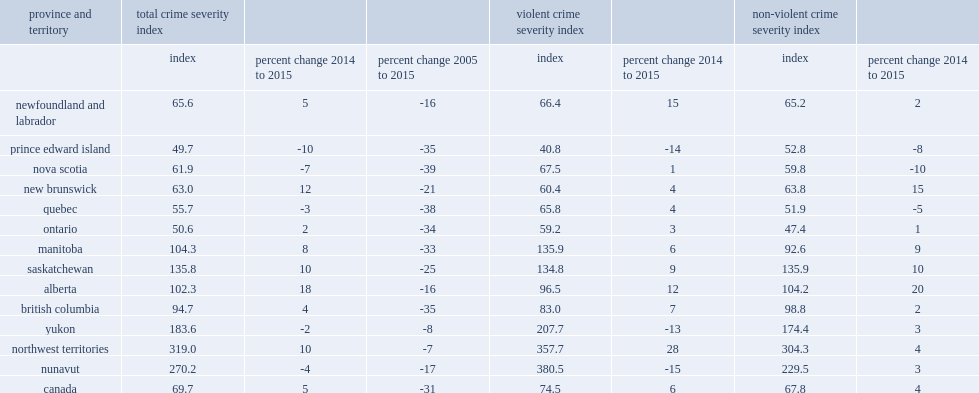About half of the increase in the national csi in 2015 can be explained by a large increase in police-reported crime in alberta, what is the percentage of the rise of the provincial csi? 18.0. What is the percentage of the provinces and territories with the largest increases in their csi were alberta? 18.0. What is the percentage of the provinces and territories with the largest increases in their csi were new brunswick? 12.0. What is the percentage of the provinces and territories with the largest increases in their csi were the northwest territories? 10.0. What is the percentage of the provinces and territories with the largest increases in their csi were saskatchewan? 10.0. In addition, what is the percentage of manitoba reported increases in the csi in 2015? 8.0. In addition, what is the percentage of newfoundland and labrador reported increases in the csi in 2015? 5.0. In addition, what is the percentage of british columbia reported increases in the csi in 2015? 4.0. In addition, what is the percentage of ontario reported increases in the csi in 2015? 2.0. What is the percentage of the exceptions to the national increase in csi of prince edward island? 10. Due to fewer reported incidents of homicide and attempted murder,what is the percentage of nunavut reported a decline in csi in 2015? 4. What is the increase in canada's violent csi in 2015 was primarily the result of increases in alberta? 12.0. What is the increase in canada's violent csi in 2015 was primarily the result of increases in british columbia? 7.0. What is the increase in canada's violent csi in 2015 was primarily the result of increases in ontario? 3.0. In addition, what is the notable increases in the violent csi in newfoundland and labrador in 2015? 15.0. In addition, what is the notable increases in the violent csi in saskatchewan in 2015? 9.0. In addition, what is the notable increases in the violent csi in manitoba in 2015? 6.0. What is the percentage of prince edward island continued to have the lowest violent csi of all provinces and territories in 2015? 14. What the percentage of alberta recorded the largest increase in non-violent csi in 2015? 20.0. What is the percentage of increases in non-violent csis were also recorded in new brunswick in 2015? 15.0. What is the percentage of increases in non-violent csis were also recorded in saskatchewan in 2015? 10.0. What is the percentage of increases in non-violent csis were also recorded in manitoba in 2015? 9.0. What is the percentage of nova scotia were there decreases in the non-violent csi in 2015? 10. What is the percentage of prince edward island were there decreases in the non-violent csi in 2015? 8. What is the percentage of quebec were there decreases in the non-violent csi in 2015? 5. 